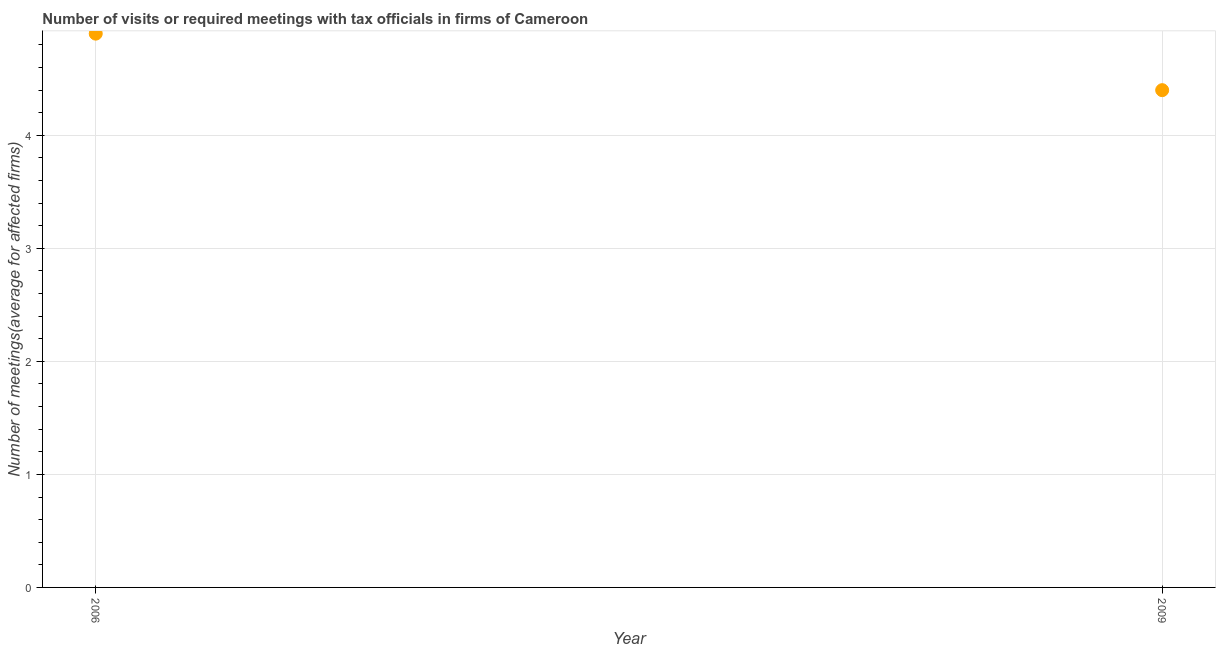What is the number of required meetings with tax officials in 2006?
Make the answer very short. 4.9. Across all years, what is the maximum number of required meetings with tax officials?
Provide a short and direct response. 4.9. In which year was the number of required meetings with tax officials minimum?
Your answer should be compact. 2009. What is the sum of the number of required meetings with tax officials?
Provide a succinct answer. 9.3. What is the average number of required meetings with tax officials per year?
Your answer should be very brief. 4.65. What is the median number of required meetings with tax officials?
Your response must be concise. 4.65. Do a majority of the years between 2009 and 2006 (inclusive) have number of required meetings with tax officials greater than 2.6 ?
Your answer should be very brief. No. What is the ratio of the number of required meetings with tax officials in 2006 to that in 2009?
Keep it short and to the point. 1.11. How many dotlines are there?
Offer a very short reply. 1. How many years are there in the graph?
Your answer should be very brief. 2. Are the values on the major ticks of Y-axis written in scientific E-notation?
Give a very brief answer. No. Does the graph contain grids?
Keep it short and to the point. Yes. What is the title of the graph?
Your answer should be compact. Number of visits or required meetings with tax officials in firms of Cameroon. What is the label or title of the X-axis?
Ensure brevity in your answer.  Year. What is the label or title of the Y-axis?
Provide a short and direct response. Number of meetings(average for affected firms). What is the Number of meetings(average for affected firms) in 2006?
Offer a terse response. 4.9. What is the Number of meetings(average for affected firms) in 2009?
Your response must be concise. 4.4. What is the difference between the Number of meetings(average for affected firms) in 2006 and 2009?
Provide a succinct answer. 0.5. What is the ratio of the Number of meetings(average for affected firms) in 2006 to that in 2009?
Provide a short and direct response. 1.11. 